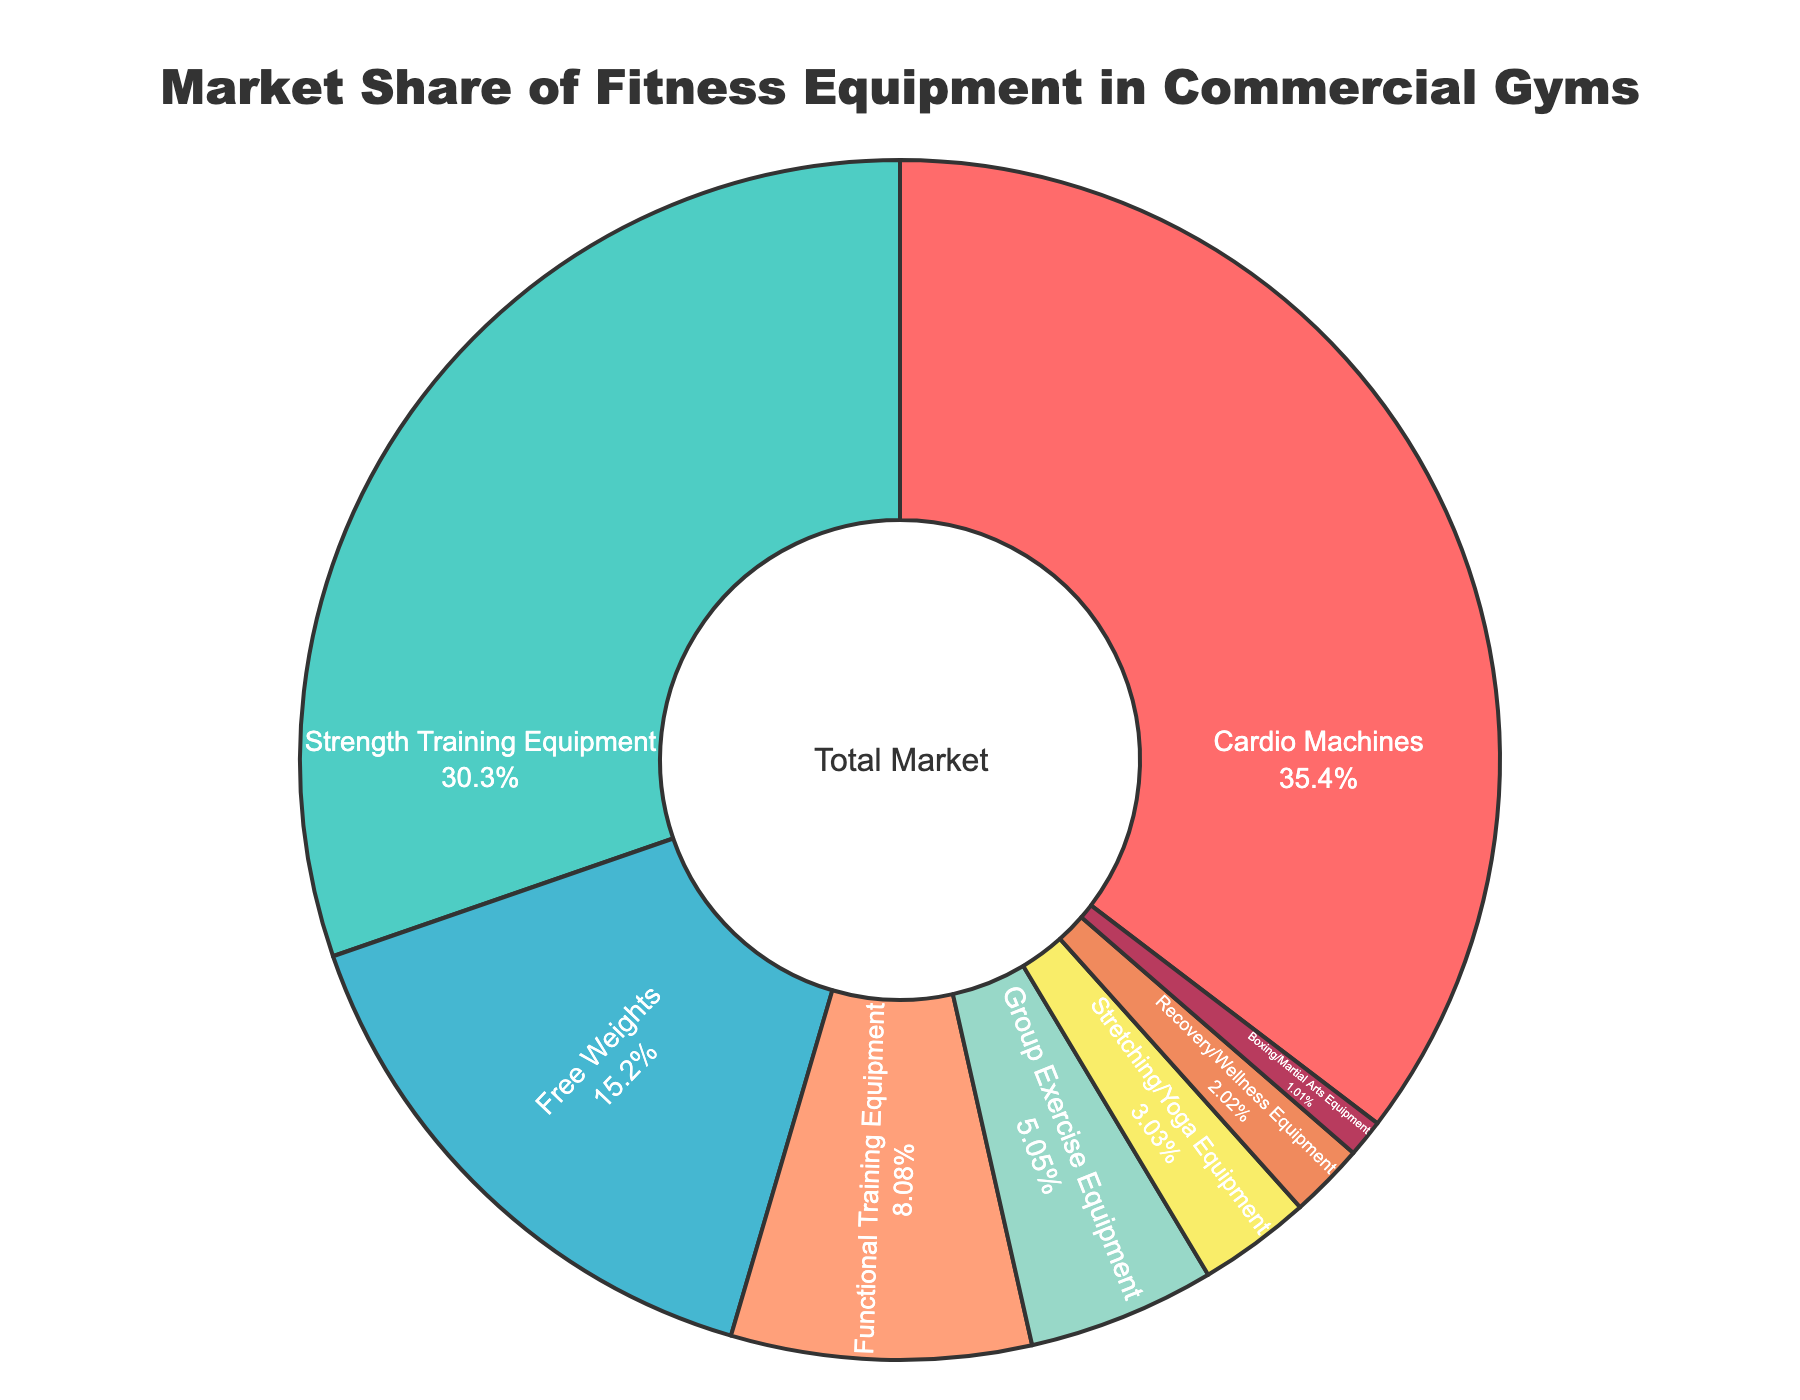What's the largest share of the market? The largest share of the market is represented by the slice with the highest percentage, which can be identified as the largest area in the pie chart. The slice labeled "Cardio Machines" holds the largest share at 35%.
Answer: Cardio Machines What's the total market share for Strength Training Equipment and Free Weights combined? To find the total market share for Strength Training Equipment and Free Weights, add their respective percentages. The percentage for Strength Training Equipment is 30%, and for Free Weights, it is 15%. So, the combined total is 30% + 15% = 45%.
Answer: 45% Which type of fitness equipment has a smaller market share, Functional Training Equipment or Group Exercise Equipment? Compare the percentages of Functional Training Equipment (8%) and Group Exercise Equipment (5%). Since 5% is less than 8%, Group Exercise Equipment has a smaller market share.
Answer: Group Exercise Equipment What is the market share difference between Cardio Machines and Stretching/Yoga Equipment? Subtract the percentage of Stretching/Yoga Equipment (3%) from the percentage of Cardio Machines (35%). The difference is 35% - 3% = 32%.
Answer: 32% How many types of equipment have a market share greater than 10%? Identify the types of equipment with percentages greater than 10%. Cardio Machines (35%), Strength Training Equipment (30%), and Free Weights (15%) all have market shares greater than 10%. There are 3 types.
Answer: 3 What is the combined market share of equipment that has less than 5% market share? Add the percentages of the types of equipment with shares less than 5%: Group Exercise Equipment (5%), Stretching/Yoga Equipment (3%), Recovery/Wellness Equipment (2%), and Boxing/Martial Arts Equipment (1%). The combined share is 5% + 3% + 2% + 1% = 11%.
Answer: 11% Which color represents the market share for Recovery/Wellness Equipment? The color for Recovery/Wellness Equipment can be identified in the legend in the pie chart. The Recovery/Wellness Equipment slice is colored in orange.
Answer: Orange What is the ratio of the market share of Cardio Machines to Boxing/Martial Arts Equipment? The market share for Cardio Machines is 35%, and for Boxing/Martial Arts Equipment, it is 1%. The ratio of 35 to 1 can be simplified to 35:1.
Answer: 35:1 Which fitness equipment types together account for more than half of the total market share? Sum the percentages of equipment types until the total exceeds 50%. Cardio Machines (35%) + Strength Training Equipment (30%) = 65%. These two types together account for 65%, which is more than half.
Answer: Cardio Machines and Strength Training Equipment What is the smallest market share shown in the chart? The smallest market share is represented by the slice with the smallest percentage, which can be identified as the smallest area in the pie chart. The slice labeled "Boxing/Martial Arts Equipment" holds the smallest share at 1%.
Answer: Boxing/Martial Arts Equipment 